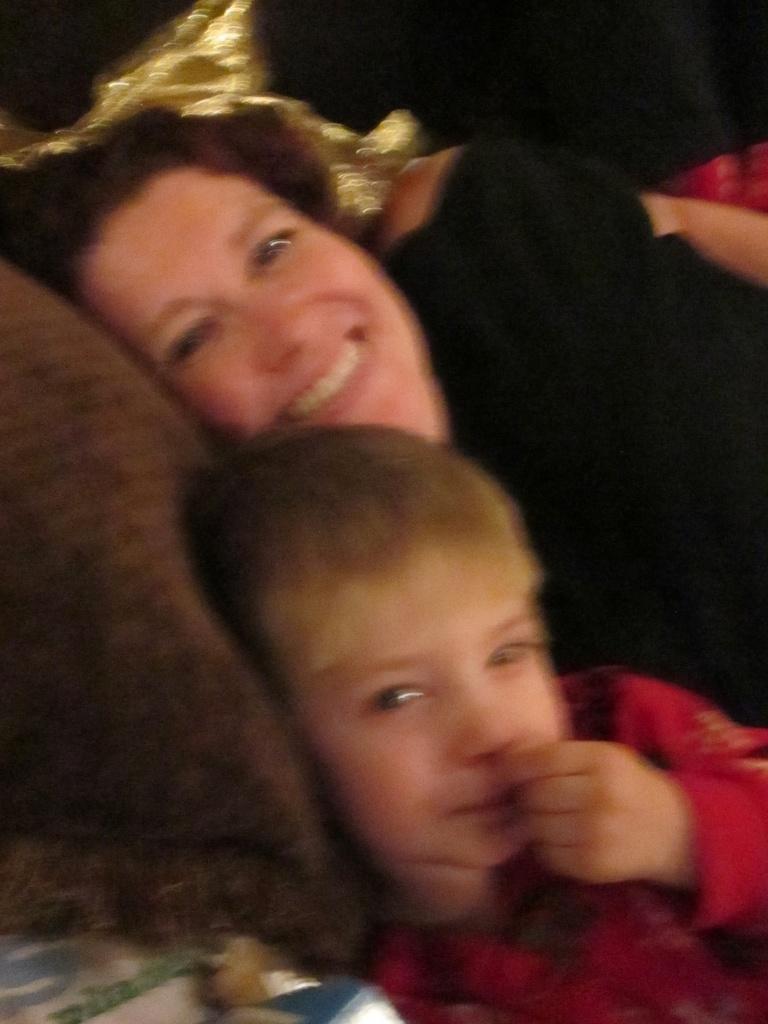How would you summarize this image in a sentence or two? In this image, we can see a lady and a kid lying on the bed and there is a pillow. 